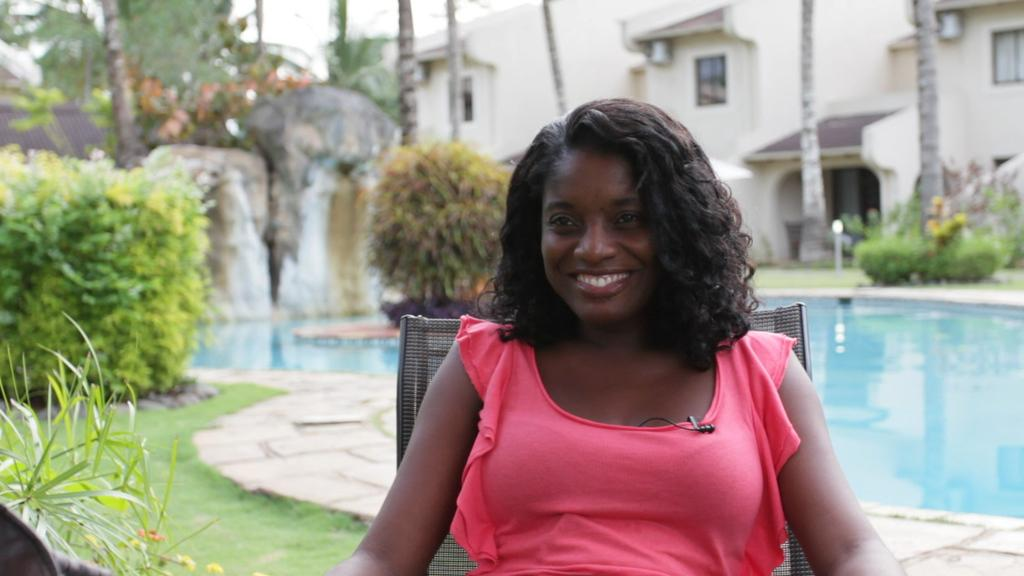Who is present in the image? There is a woman in the image. What is the woman doing in the image? The woman is sitting on a chair. What is the woman's facial expression in the image? The woman is smiling. What can be seen in the background of the image? There is a swimming pool, trees, plants, grass, and a building in the background of the image. What type of bat is flying over the woman's knee in the image? There is no bat present in the image, and the woman's knee is not visible. 